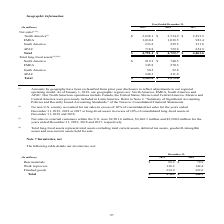According to Sealed Air Corporation's financial document, What was the change in geographic classification? Our North American operations include Canada, the United States, Mexico and Central America. Mexico and Central America were previously included in Latin America.. The document states: "are: North America, EMEA, South America and APAC. Our North American operations include Canada, the United States, Mexico and Central America. Mexico ..." Also, What are total long-lived assets? Total long-lived assets represent total assets excluding total current assets, deferred tax assets, goodwill, intangible assets and non-current assets held for sale.. The document states: "(4) Total long-lived assets represent total assets excluding total current assets, deferred tax assets, goodwill, intangible assets and non-current as..." Also, What years are included in the table? The document contains multiple relevant values: 2019, 2018, 2017. From the document: "(In millions) 2019 2018 2017 (In millions) 2019 2018 2017 (In millions) 2019 2018 2017..." Also, can you calculate: What was the net sales to customers in North America who are not in the U.S. in 2019? Based on the calculation: 2,828.1-2,501.6, the result is 326.5 (in millions). This is based on the information: "North America (3) $ 2,828.1 $ 2,734.9 $ 2,591.5 sales to external customers within the U.S. were $2,501.6 million, $2,402.3 million and $2,280.0 million for the years ended December 31, 2019, 2018 and..." The key data points involved are: 2,501.6, 2,828.1. Also, can you calculate: What is the growth rate of total net sales for 2018 to 2019? To answer this question, I need to perform calculations using the financial data. The calculation is: (4,791.1-4,732.7)/4,732.7, which equals 1.23 (percentage). This is based on the information: "Total $ 4,791.1 $ 4,732.7 $ 4,461.6 Total $ 4,791.1 $ 4,732.7 $ 4,461.6..." The key data points involved are: 4,732.7, 4,791.1. Also, can you calculate: What is of Total long-lived assets for North America expressed as a percentage to all other regions in 2019? To answer this question, I need to perform calculations using the financial data. The calculation is: 919.3/(1,563.6-919.3), which equals 142.68 (percentage). This is based on the information: "North America $ 919.3 $ 740.5 EMEA 345.8 270.5 South America 50.2 52.8 APAC 248.3 211.8 Total $ 1,563.6 $ 1,275.6 South America 50.2 52.8 APAC 248.3 211.8 Total $ 1,563.6 $ 1,275.6..." The key data points involved are: 1,563.6, 919.3. 